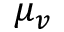Convert formula to latex. <formula><loc_0><loc_0><loc_500><loc_500>\mu _ { v }</formula> 